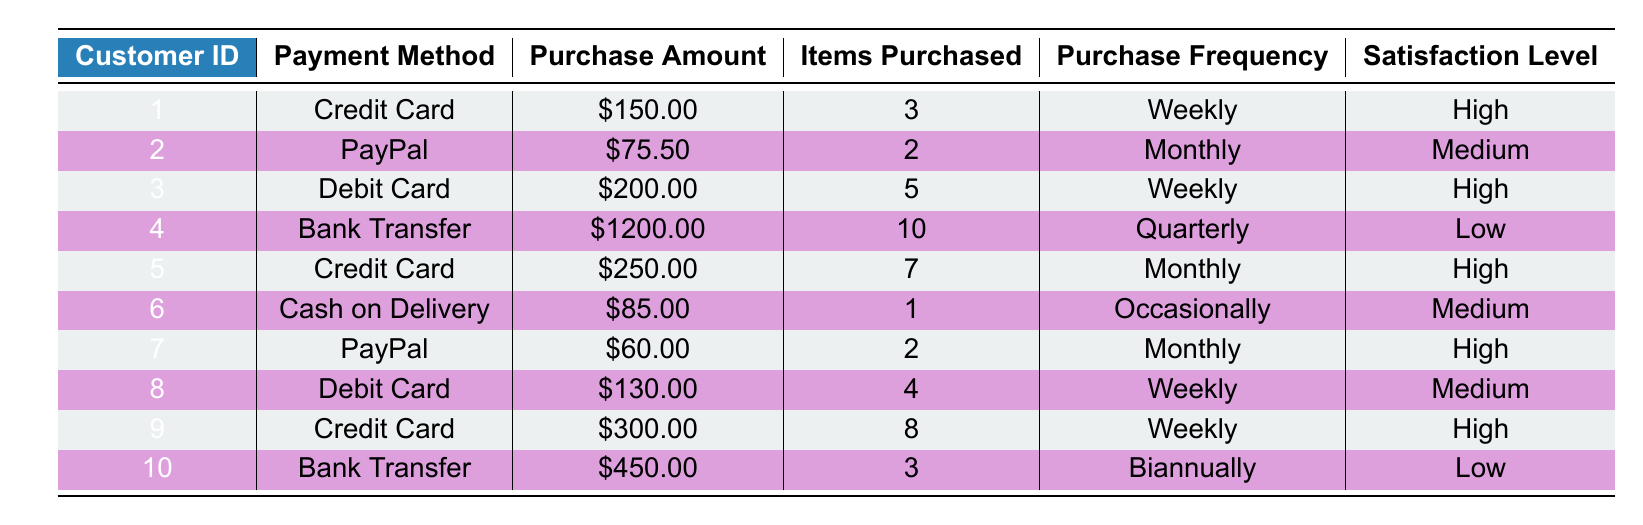What is the highest purchase amount made by a customer? By looking at the table, we see that the maximum purchase amount is listed in the row for Customer ID 4, which shows a purchase amount of 1200.00
Answer: 1200.00 How many customers used PayPal as their payment method? There are two customers listed with PayPal as their payment method (Customer ID 2 and Customer ID 7), as we can find both in the 'Payment Method' column
Answer: 2 What is the average purchase amount for customers who paid with a Credit Card? The customers using a Credit Card are Customer ID 1 ($150.00), Customer ID 5 ($250.00), and Customer ID 9 ($300.00). To find the average, we add these amounts: 150.00 + 250.00 + 300.00 = 700.00, then divide by 3 (the number of customers), resulting in an average of 700.00/3 = 233.33
Answer: 233.33 Are there any customers who have a high satisfaction level and made a purchase using a Bank Transfer? Checking the table, Customer ID 4 and Customer ID 10 used Bank Transfer, but both have a satisfaction level of 'Low'. Therefore, there are no customers with a 'High' satisfaction level using Bank Transfer
Answer: No What is the total number of items purchased by customers who made their payments with a Debit Card? Referring to the relevant rows, Customer ID 3 purchased 5 items, and Customer ID 8 purchased 4 items. We sum these together: 5 + 4 = 9, which represents the total number of items purchased with a Debit Card
Answer: 9 